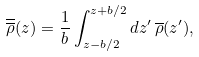Convert formula to latex. <formula><loc_0><loc_0><loc_500><loc_500>\overline { \overline { \rho } } ( z ) = \frac { 1 } { b } \int _ { z - b / 2 } ^ { z + b / 2 } d z ^ { \prime } \, \overline { \rho } ( z ^ { \prime } ) ,</formula> 